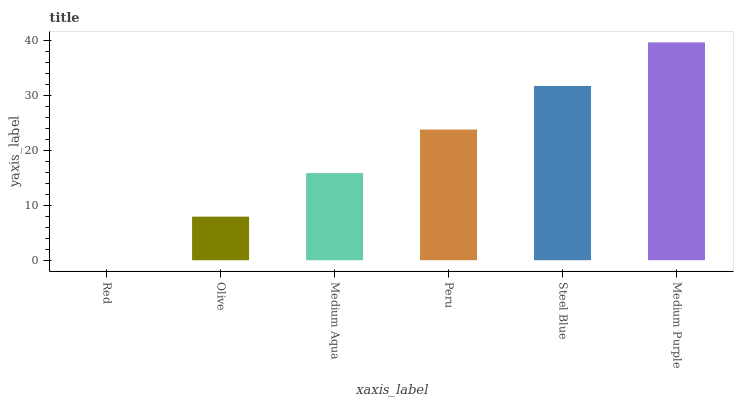Is Red the minimum?
Answer yes or no. Yes. Is Medium Purple the maximum?
Answer yes or no. Yes. Is Olive the minimum?
Answer yes or no. No. Is Olive the maximum?
Answer yes or no. No. Is Olive greater than Red?
Answer yes or no. Yes. Is Red less than Olive?
Answer yes or no. Yes. Is Red greater than Olive?
Answer yes or no. No. Is Olive less than Red?
Answer yes or no. No. Is Peru the high median?
Answer yes or no. Yes. Is Medium Aqua the low median?
Answer yes or no. Yes. Is Medium Aqua the high median?
Answer yes or no. No. Is Peru the low median?
Answer yes or no. No. 